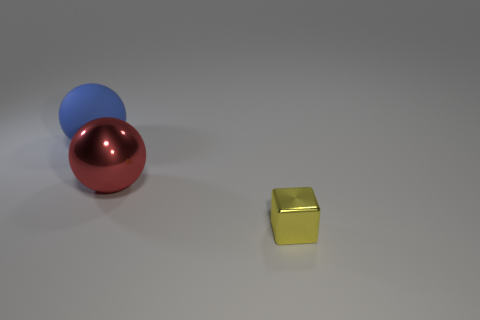Add 3 red shiny things. How many objects exist? 6 Subtract all cubes. How many objects are left? 2 Add 2 red objects. How many red objects exist? 3 Subtract 0 green blocks. How many objects are left? 3 Subtract all metallic cubes. Subtract all purple matte things. How many objects are left? 2 Add 1 metallic objects. How many metallic objects are left? 3 